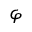<formula> <loc_0><loc_0><loc_500><loc_500>\varphi</formula> 